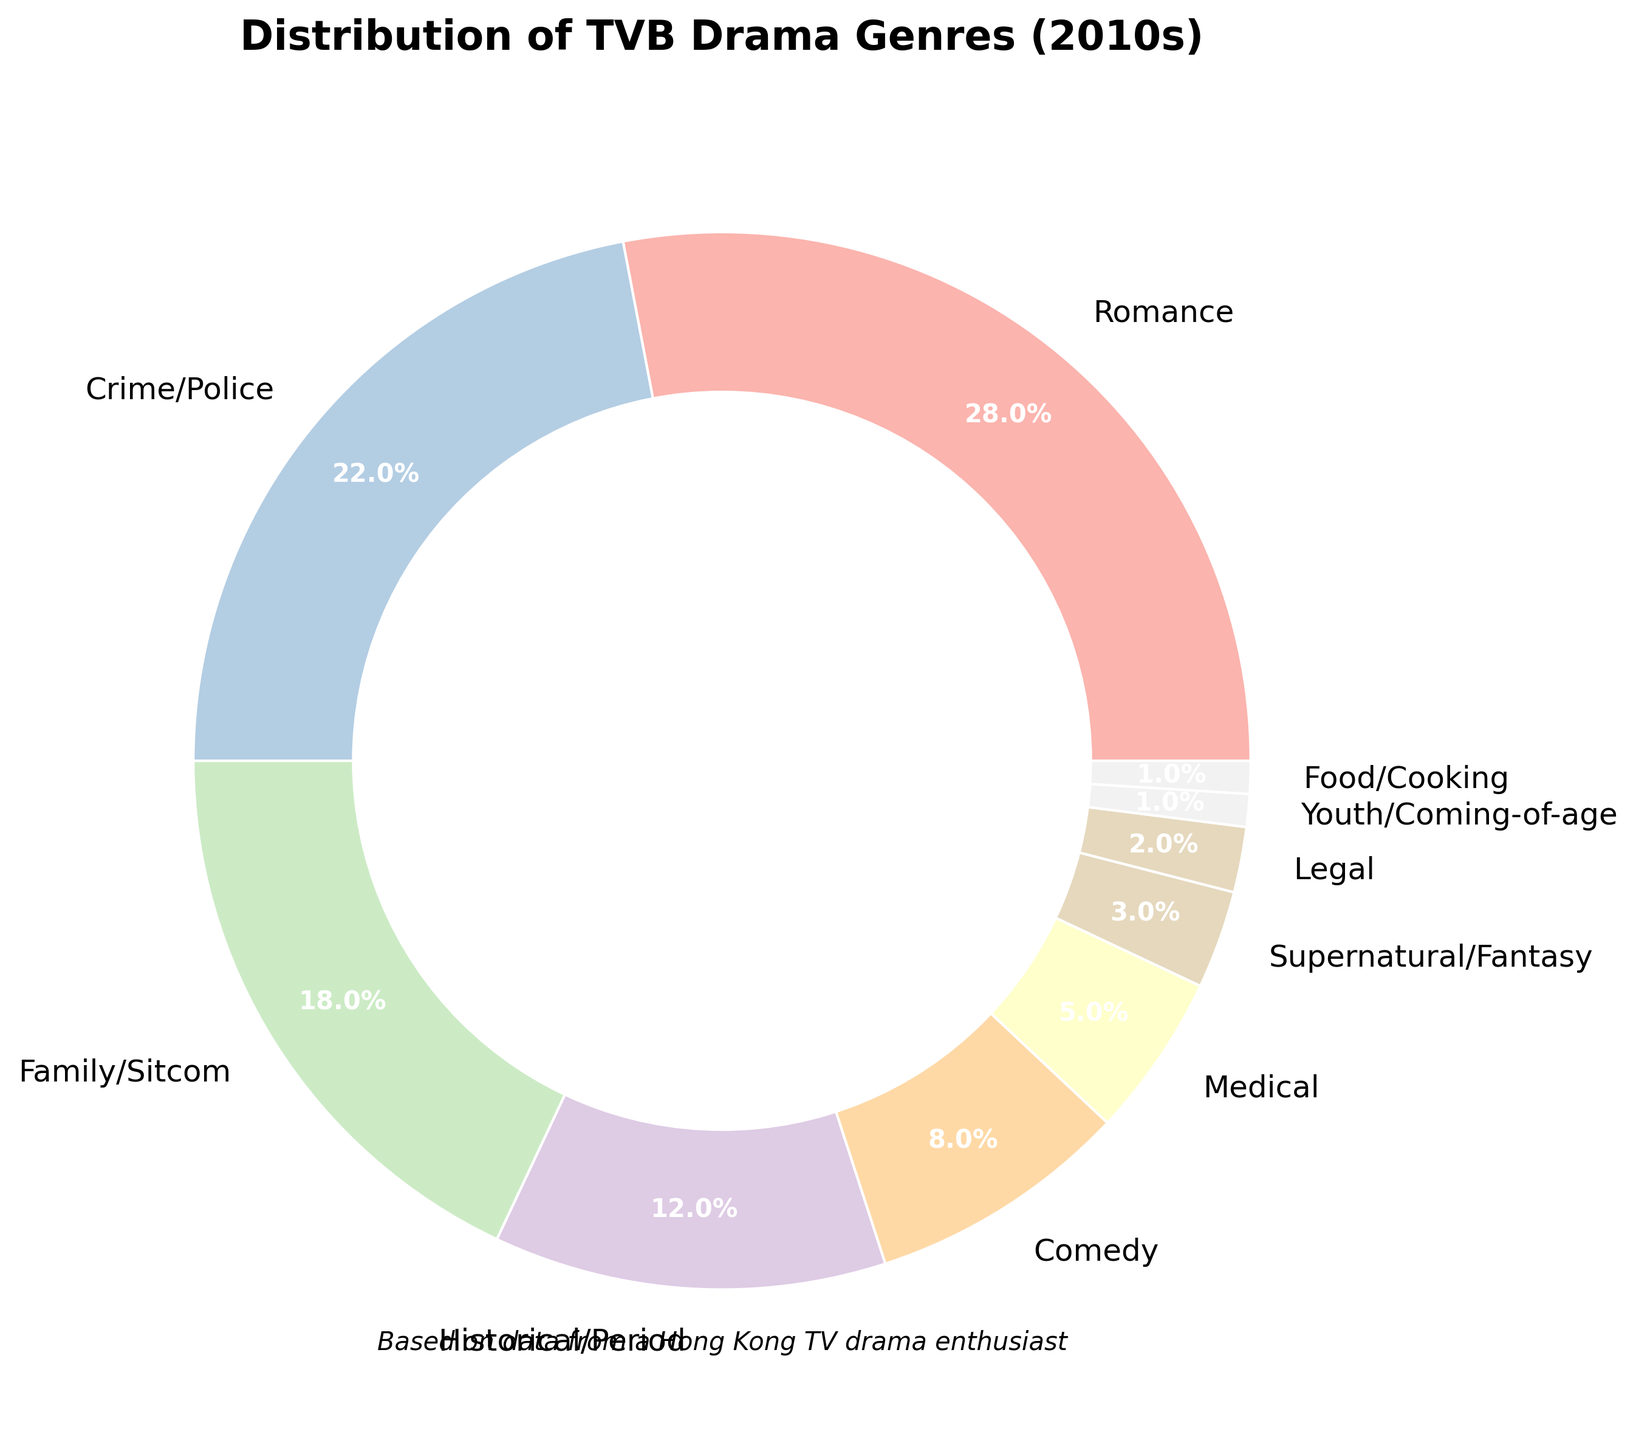Which genre had the highest percentage of TVB dramas in the 2010s? To find the genre with the highest percentage, look at the largest slice of the pie chart. The largest slice is labeled "Romance," with 28%.
Answer: Romance What percentage of TVB dramas were in the Crime/Police and Medical genres combined? Add the percentages of the Crime/Police genre and the Medical genre. Crime/Police is 22% and Medical is 5%. So, 22% + 5% = 27%.
Answer: 27% How does the percentage of Comedy dramas compare to that of Historical/Period dramas? Look at the sizes of the slices for Comedy and Historical/Period genres. Comedy is 8% and Historical/Period is 12%. Thus, Historical/Period has a larger percentage than Comedy.
Answer: Historical/Period has a 4% higher percentage than Comedy Which two genres have the smallest percentages, and what are their combined percentages? The smallest slices correspond to the genres with the smallest percentages. These are Youth/Coming-of-age (1%) and Food/Cooking (1%). Adding these gives 1% + 1% = 2%.
Answer: Youth/Coming-of-age and Food/Cooking, 2% Identify the genre with the fourth-highest percentage and state its value. List the percentages in descending order: 28%, 22%, 18%, 12%, etc. The fourth-highest percentage is 12%, which corresponds to Historical/Period.
Answer: Historical/Period, 12% How many genres have a percentage equal to or greater than 10%? Count the slices that are labeled with percentages equal to or greater than 10%. The genres are Romance (28%), Crime/Police (22%), Family/Sitcom (18%), and Historical/Period (12%), totaling 4 genres.
Answer: 4 genres If you combine the percentages of all genres listed as less than 10%, what total percentage do you get? Add the percentages of the genres with less than 10%. These are Comedy (8%), Medical (5%), Supernatural/Fantasy (3%), Legal (2%), Youth/Coming-of-age (1%), and Food/Cooking (1%). So, 8% + 5% + 3% + 2% + 1% + 1% = 20%.
Answer: 20% What visual attribute makes it clear that the pie chart represents a donut chart rather than a full pie chart? Identify the visual feature that distinguishes a donut chart from a pie chart. A donut chart has a circle cut out in the center, making it look like a donut.
Answer: The circle at the center Compare the sizes of the slices for Family/Sitcom and Comedy genres. Which slice is larger and by what percentage? Look at the sizes of the Family/Sitcom and Comedy slices. Family/Sitcom is 18% and Comedy is 8%. The difference is 18% - 8% = 10%.
Answer: Family/Sitcom slice is larger by 10% 